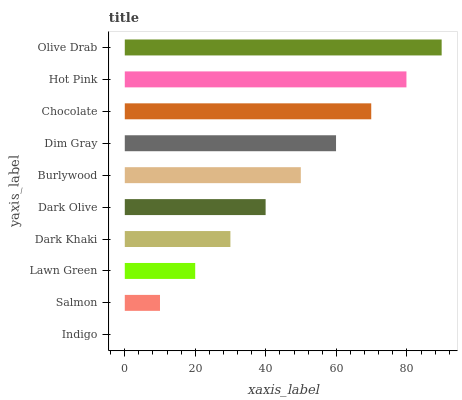Is Indigo the minimum?
Answer yes or no. Yes. Is Olive Drab the maximum?
Answer yes or no. Yes. Is Salmon the minimum?
Answer yes or no. No. Is Salmon the maximum?
Answer yes or no. No. Is Salmon greater than Indigo?
Answer yes or no. Yes. Is Indigo less than Salmon?
Answer yes or no. Yes. Is Indigo greater than Salmon?
Answer yes or no. No. Is Salmon less than Indigo?
Answer yes or no. No. Is Burlywood the high median?
Answer yes or no. Yes. Is Dark Olive the low median?
Answer yes or no. Yes. Is Salmon the high median?
Answer yes or no. No. Is Olive Drab the low median?
Answer yes or no. No. 